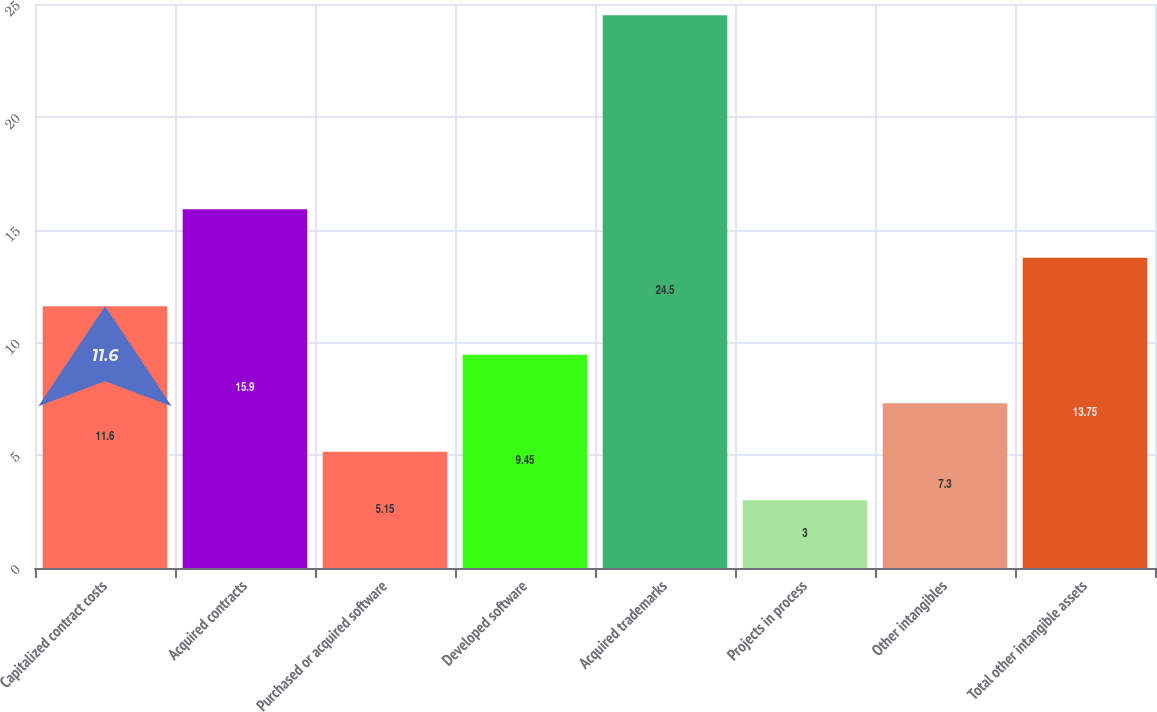Convert chart. <chart><loc_0><loc_0><loc_500><loc_500><bar_chart><fcel>Capitalized contract costs<fcel>Acquired contracts<fcel>Purchased or acquired software<fcel>Developed software<fcel>Acquired trademarks<fcel>Projects in process<fcel>Other intangibles<fcel>Total other intangible assets<nl><fcel>11.6<fcel>15.9<fcel>5.15<fcel>9.45<fcel>24.5<fcel>3<fcel>7.3<fcel>13.75<nl></chart> 